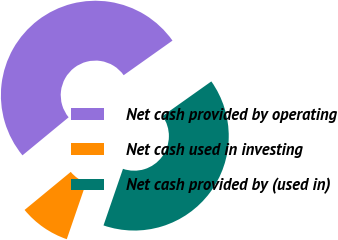<chart> <loc_0><loc_0><loc_500><loc_500><pie_chart><fcel>Net cash provided by operating<fcel>Net cash used in investing<fcel>Net cash provided by (used in)<nl><fcel>51.16%<fcel>8.76%<fcel>40.09%<nl></chart> 